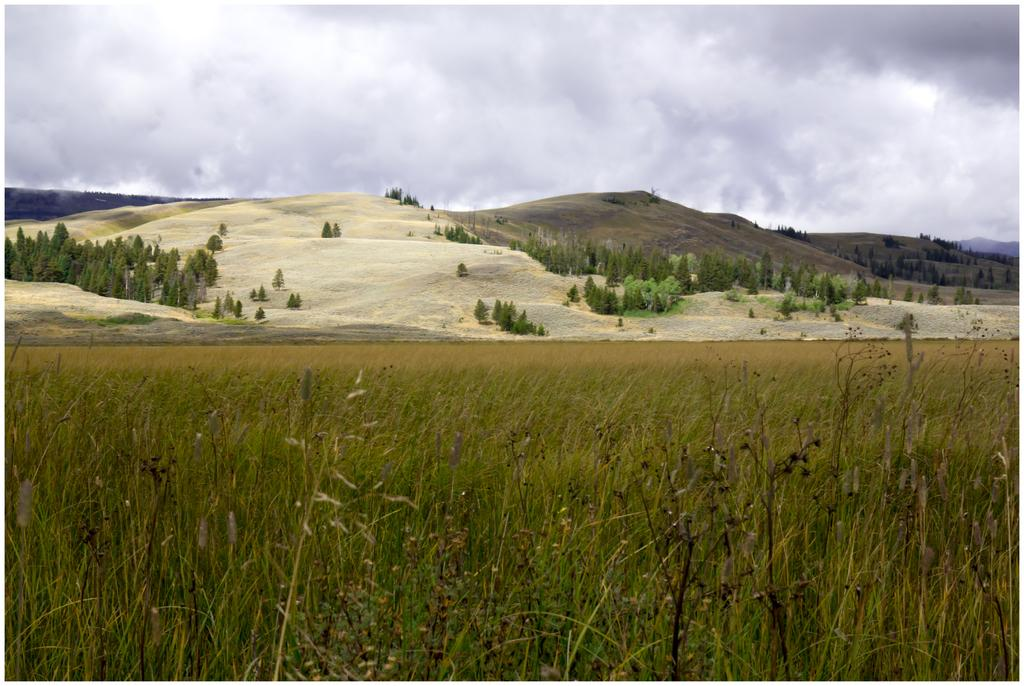What type of vegetation is in the front of the image? There are dry plants in the front of the image. What can be seen in the background of the image? There are trees and mountains in the background of the image. What is the condition of the sky in the image? The sky is cloudy in the image. What type of badge is visible on the trees in the image? There is no badge present on the trees in the image. What disease affects the dry plants in the image? There is no information about any disease affecting the dry plants in the image. 